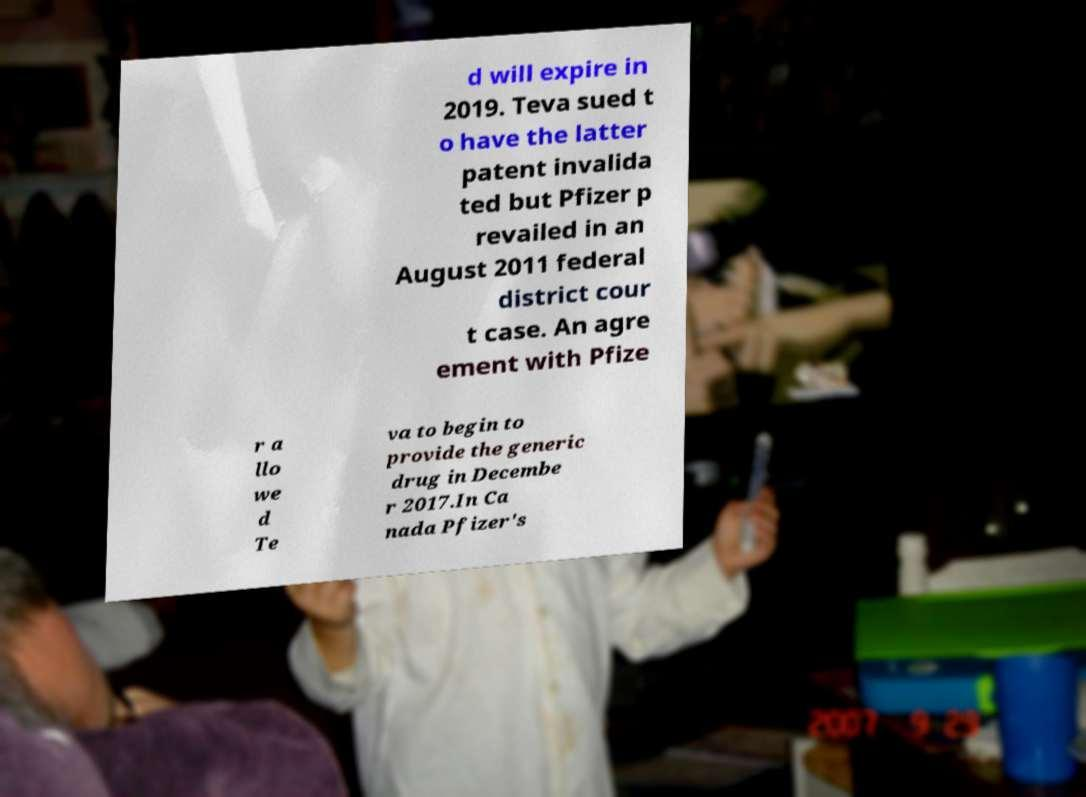Could you assist in decoding the text presented in this image and type it out clearly? d will expire in 2019. Teva sued t o have the latter patent invalida ted but Pfizer p revailed in an August 2011 federal district cour t case. An agre ement with Pfize r a llo we d Te va to begin to provide the generic drug in Decembe r 2017.In Ca nada Pfizer's 